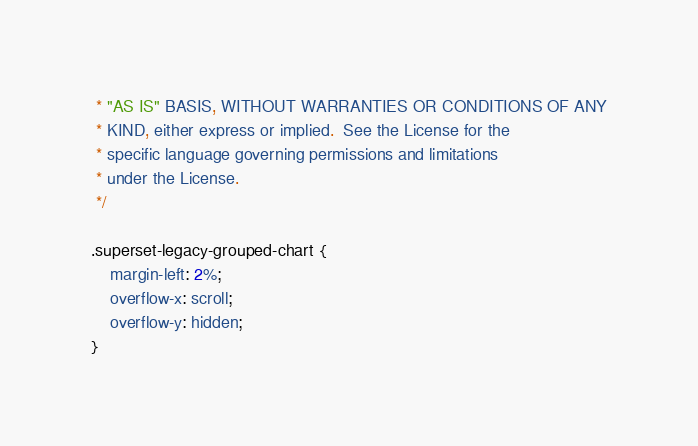<code> <loc_0><loc_0><loc_500><loc_500><_CSS_> * "AS IS" BASIS, WITHOUT WARRANTIES OR CONDITIONS OF ANY
 * KIND, either express or implied.  See the License for the
 * specific language governing permissions and limitations
 * under the License.
 */

.superset-legacy-grouped-chart {
    margin-left: 2%;
    overflow-x: scroll;
    overflow-y: hidden;
}</code> 